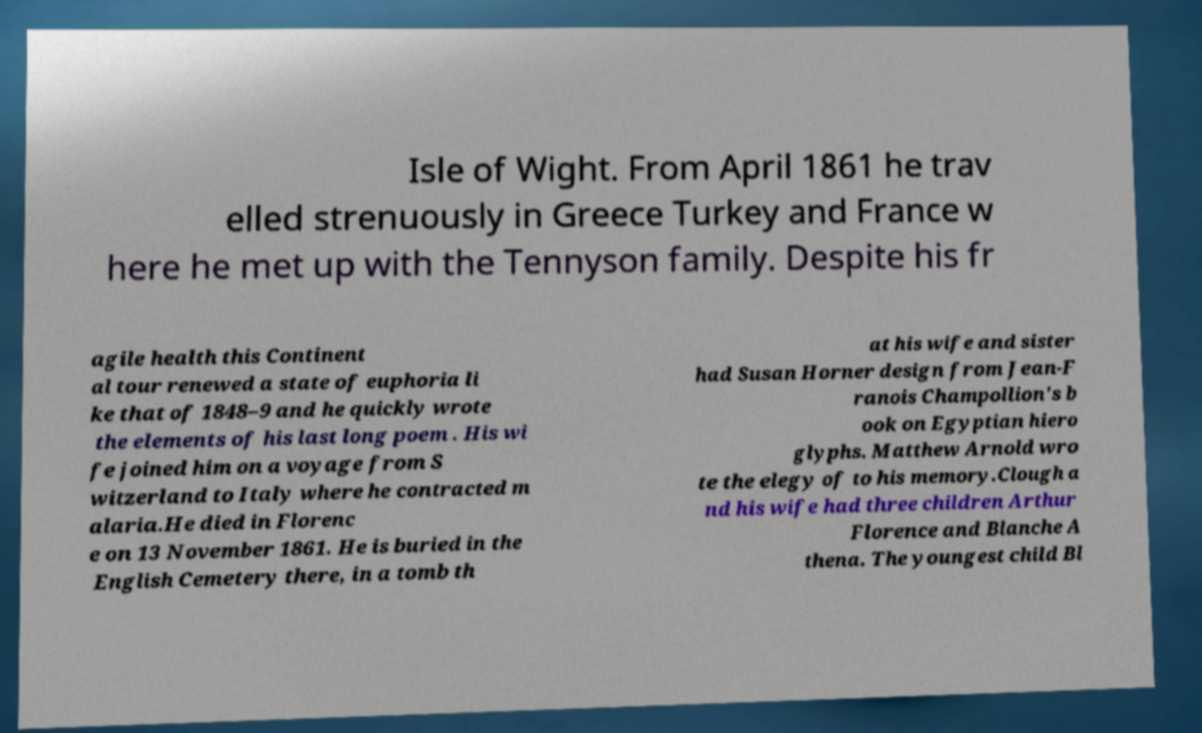Can you read and provide the text displayed in the image?This photo seems to have some interesting text. Can you extract and type it out for me? Isle of Wight. From April 1861 he trav elled strenuously in Greece Turkey and France w here he met up with the Tennyson family. Despite his fr agile health this Continent al tour renewed a state of euphoria li ke that of 1848–9 and he quickly wrote the elements of his last long poem . His wi fe joined him on a voyage from S witzerland to Italy where he contracted m alaria.He died in Florenc e on 13 November 1861. He is buried in the English Cemetery there, in a tomb th at his wife and sister had Susan Horner design from Jean-F ranois Champollion's b ook on Egyptian hiero glyphs. Matthew Arnold wro te the elegy of to his memory.Clough a nd his wife had three children Arthur Florence and Blanche A thena. The youngest child Bl 